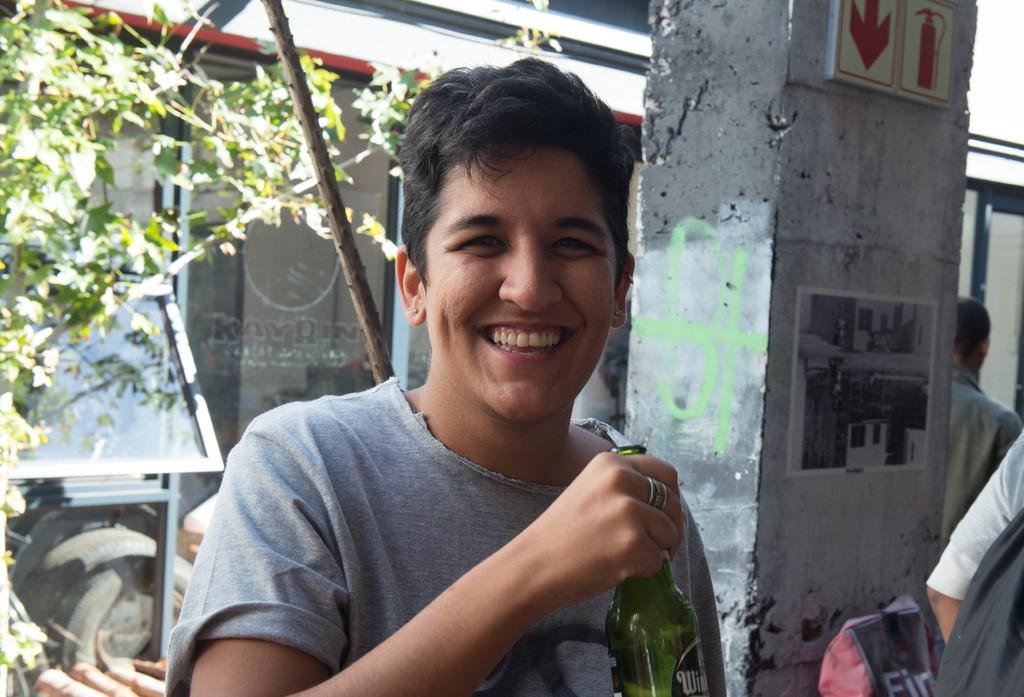Who is the main subject in the image? There is a woman in the image. What is the woman doing in the image? The woman is posing for the camera. What is the woman holding in the image? The woman is holding a beer bottle. What can be seen in the background of the image? There is a pillar in the background of the image. Are there any other people in the image besides the woman? Yes, there are men standing in the image. What type of plot is being discussed by the woman in the image? There is no indication in the image that the woman is discussing a plot, as she is posing for the camera and holding a beer bottle. 